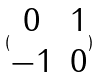<formula> <loc_0><loc_0><loc_500><loc_500>( \begin{matrix} 0 & 1 \\ - 1 & 0 \\ \end{matrix} )</formula> 